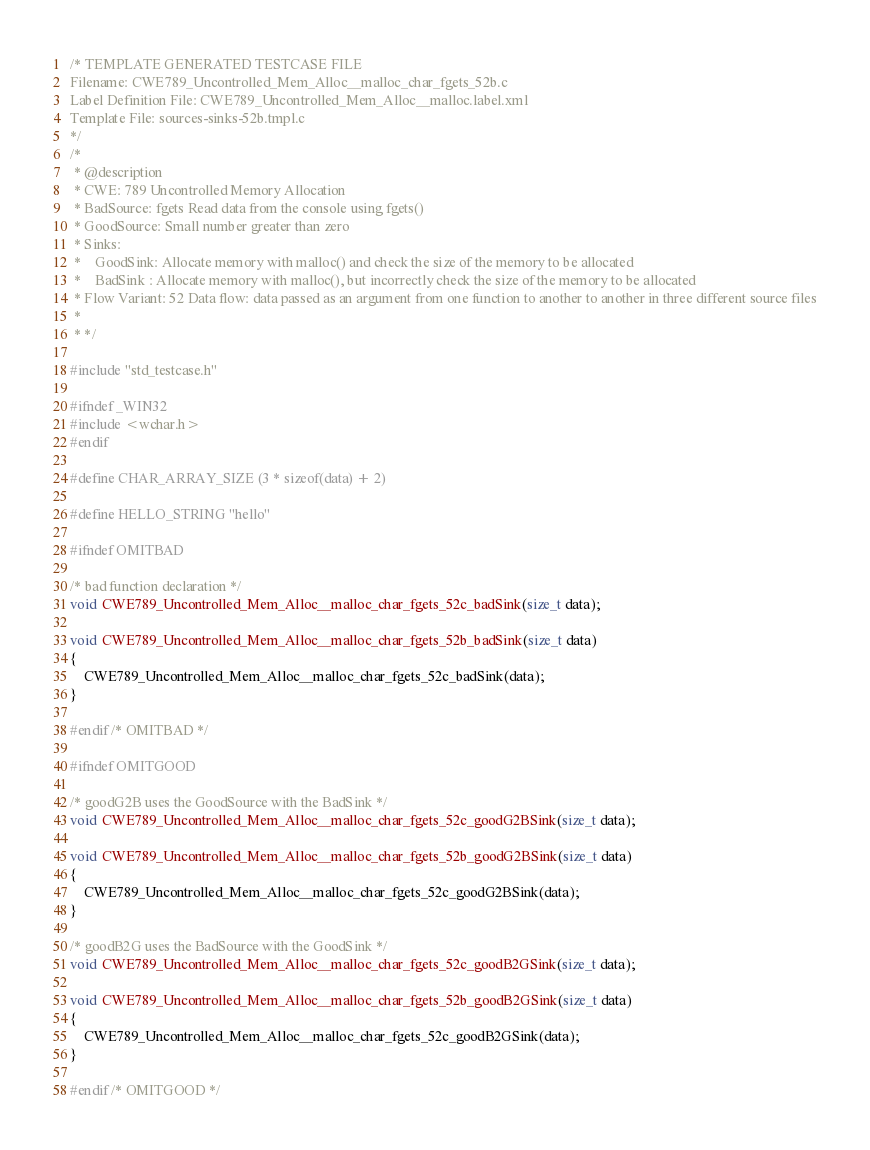<code> <loc_0><loc_0><loc_500><loc_500><_C_>/* TEMPLATE GENERATED TESTCASE FILE
Filename: CWE789_Uncontrolled_Mem_Alloc__malloc_char_fgets_52b.c
Label Definition File: CWE789_Uncontrolled_Mem_Alloc__malloc.label.xml
Template File: sources-sinks-52b.tmpl.c
*/
/*
 * @description
 * CWE: 789 Uncontrolled Memory Allocation
 * BadSource: fgets Read data from the console using fgets()
 * GoodSource: Small number greater than zero
 * Sinks:
 *    GoodSink: Allocate memory with malloc() and check the size of the memory to be allocated
 *    BadSink : Allocate memory with malloc(), but incorrectly check the size of the memory to be allocated
 * Flow Variant: 52 Data flow: data passed as an argument from one function to another to another in three different source files
 *
 * */

#include "std_testcase.h"

#ifndef _WIN32
#include <wchar.h>
#endif

#define CHAR_ARRAY_SIZE (3 * sizeof(data) + 2)

#define HELLO_STRING "hello"

#ifndef OMITBAD

/* bad function declaration */
void CWE789_Uncontrolled_Mem_Alloc__malloc_char_fgets_52c_badSink(size_t data);

void CWE789_Uncontrolled_Mem_Alloc__malloc_char_fgets_52b_badSink(size_t data)
{
    CWE789_Uncontrolled_Mem_Alloc__malloc_char_fgets_52c_badSink(data);
}

#endif /* OMITBAD */

#ifndef OMITGOOD

/* goodG2B uses the GoodSource with the BadSink */
void CWE789_Uncontrolled_Mem_Alloc__malloc_char_fgets_52c_goodG2BSink(size_t data);

void CWE789_Uncontrolled_Mem_Alloc__malloc_char_fgets_52b_goodG2BSink(size_t data)
{
    CWE789_Uncontrolled_Mem_Alloc__malloc_char_fgets_52c_goodG2BSink(data);
}

/* goodB2G uses the BadSource with the GoodSink */
void CWE789_Uncontrolled_Mem_Alloc__malloc_char_fgets_52c_goodB2GSink(size_t data);

void CWE789_Uncontrolled_Mem_Alloc__malloc_char_fgets_52b_goodB2GSink(size_t data)
{
    CWE789_Uncontrolled_Mem_Alloc__malloc_char_fgets_52c_goodB2GSink(data);
}

#endif /* OMITGOOD */
</code> 